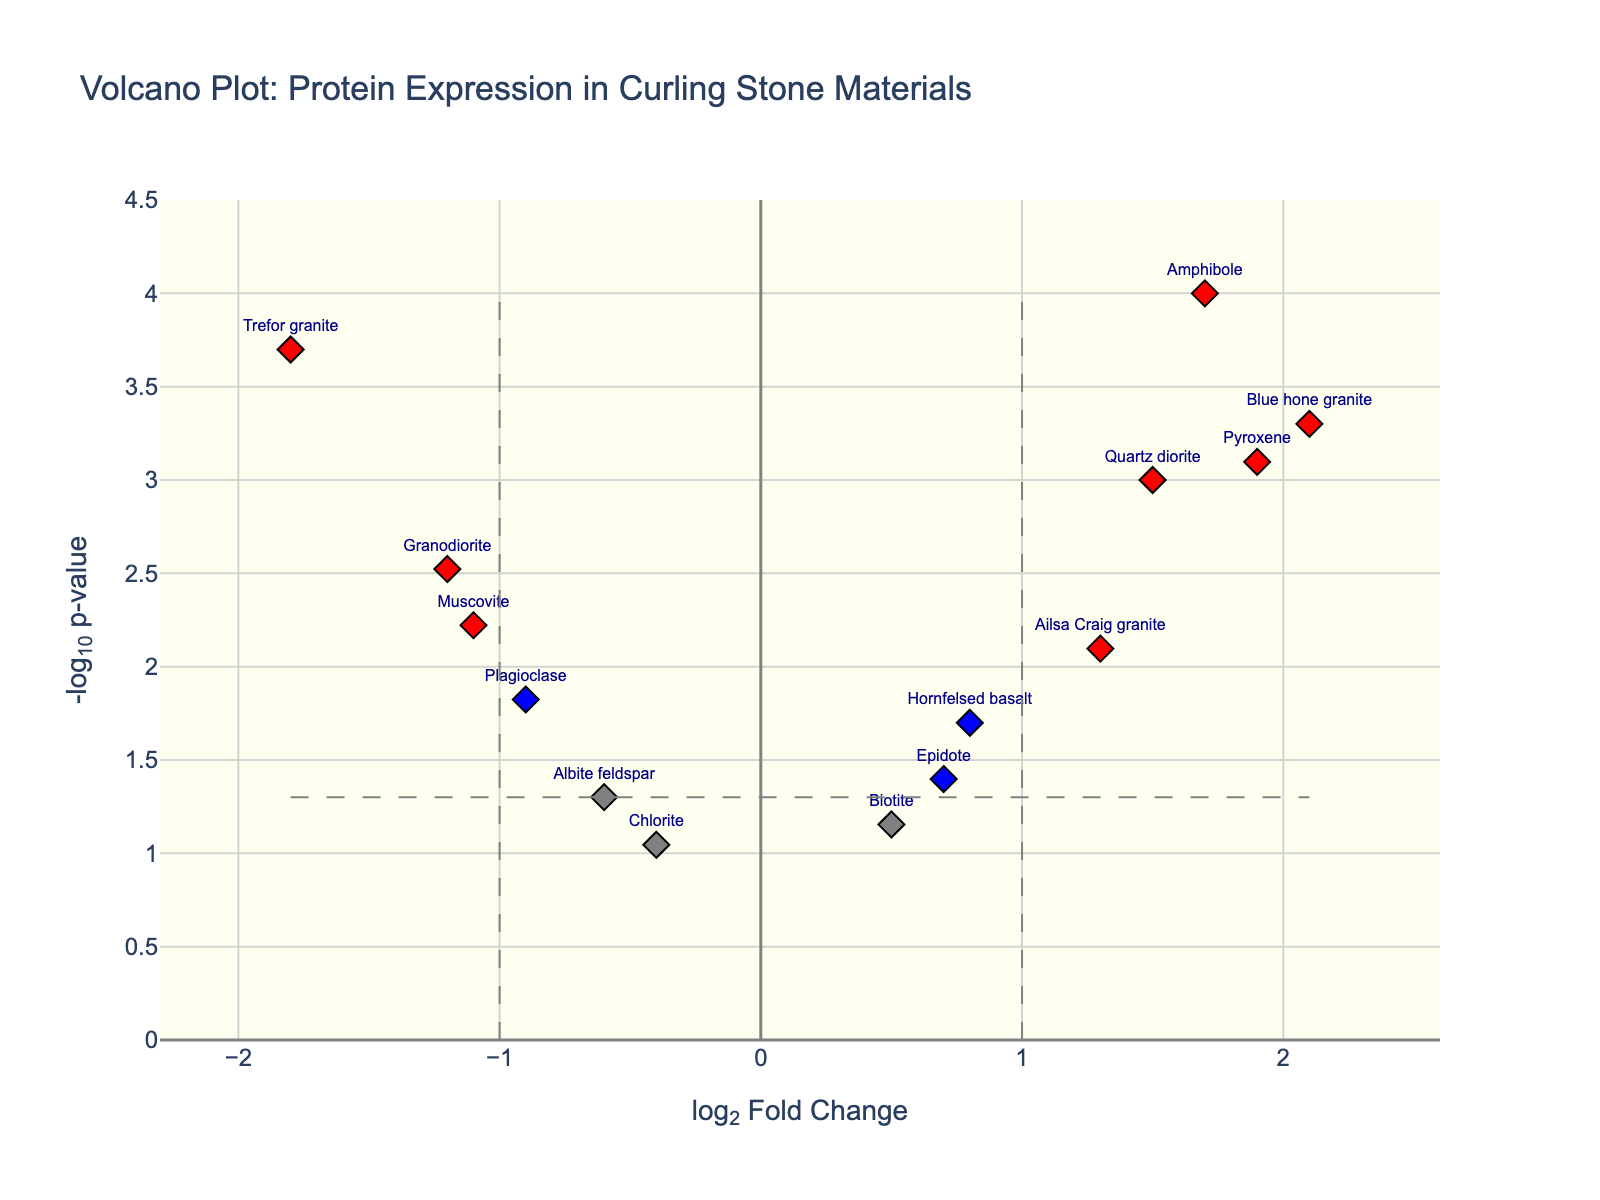What is the title of the figure? The title is typically displayed at the top of the plot. In this case, the title is "Volcano Plot: Protein Expression in Curling Stone Materials," which indicates the subject matter of the plot.
Answer: Volcano Plot: Protein Expression in Curling Stone Materials How many proteins are indicated by red markers? Red markers are used to signify proteins with both significant fold change and p-value thresholds. By visually counting the number of red markers in the plot, we can determine the number of such proteins.
Answer: 5 What does a blue diamond marker represent? The colors of the markers indicate the various significance levels. Blue markers represent proteins with a p-value below the threshold but absolute log2 fold change within the threshold.
Answer: Proteins with significant p-value but non-significant fold change Which protein has the highest -log10(p-value)? The height of the marker on the y-axis represents the -log10(p-value). By identifying the highest marker, we can find the corresponding protein.
Answer: Amphibole What log2 fold change value acts as the threshold in this plot? Vertical dashed lines represent the log2 fold change thresholds. These lines are placed at specific x-axis values, which are ±1 in this plot.
Answer: ±1 Which protein has the highest log2 fold change, and what is its -log10(p-value)? To find the protein with the highest log2 fold change, identify the point farthest to the right. Then, check its y-axis value for the corresponding -log10(p-value).
Answer: Blue hone granite, 3.301 How many proteins have a -log10(p-value) greater than 1.3? A -log10(p-value) of 1.3 corresponds roughly to a p-value of 0.05. By counting the markers above this threshold line, we can determine the number of such proteins.
Answer: 10 Between Trefor granite and Quartz diorite, which has a more significant p-value? The more significant p-value corresponds to the higher -log10(p-value). By comparing the heights of the markers for these two proteins, we determine which one is higher.
Answer: Trefor granite What color corresponds to proteins with non-significant fold change and non-significant p-value? Non-significant proteins based on both thresholds are represented with a specific color. By examining these markers, we identify the color used.
Answer: Grey 